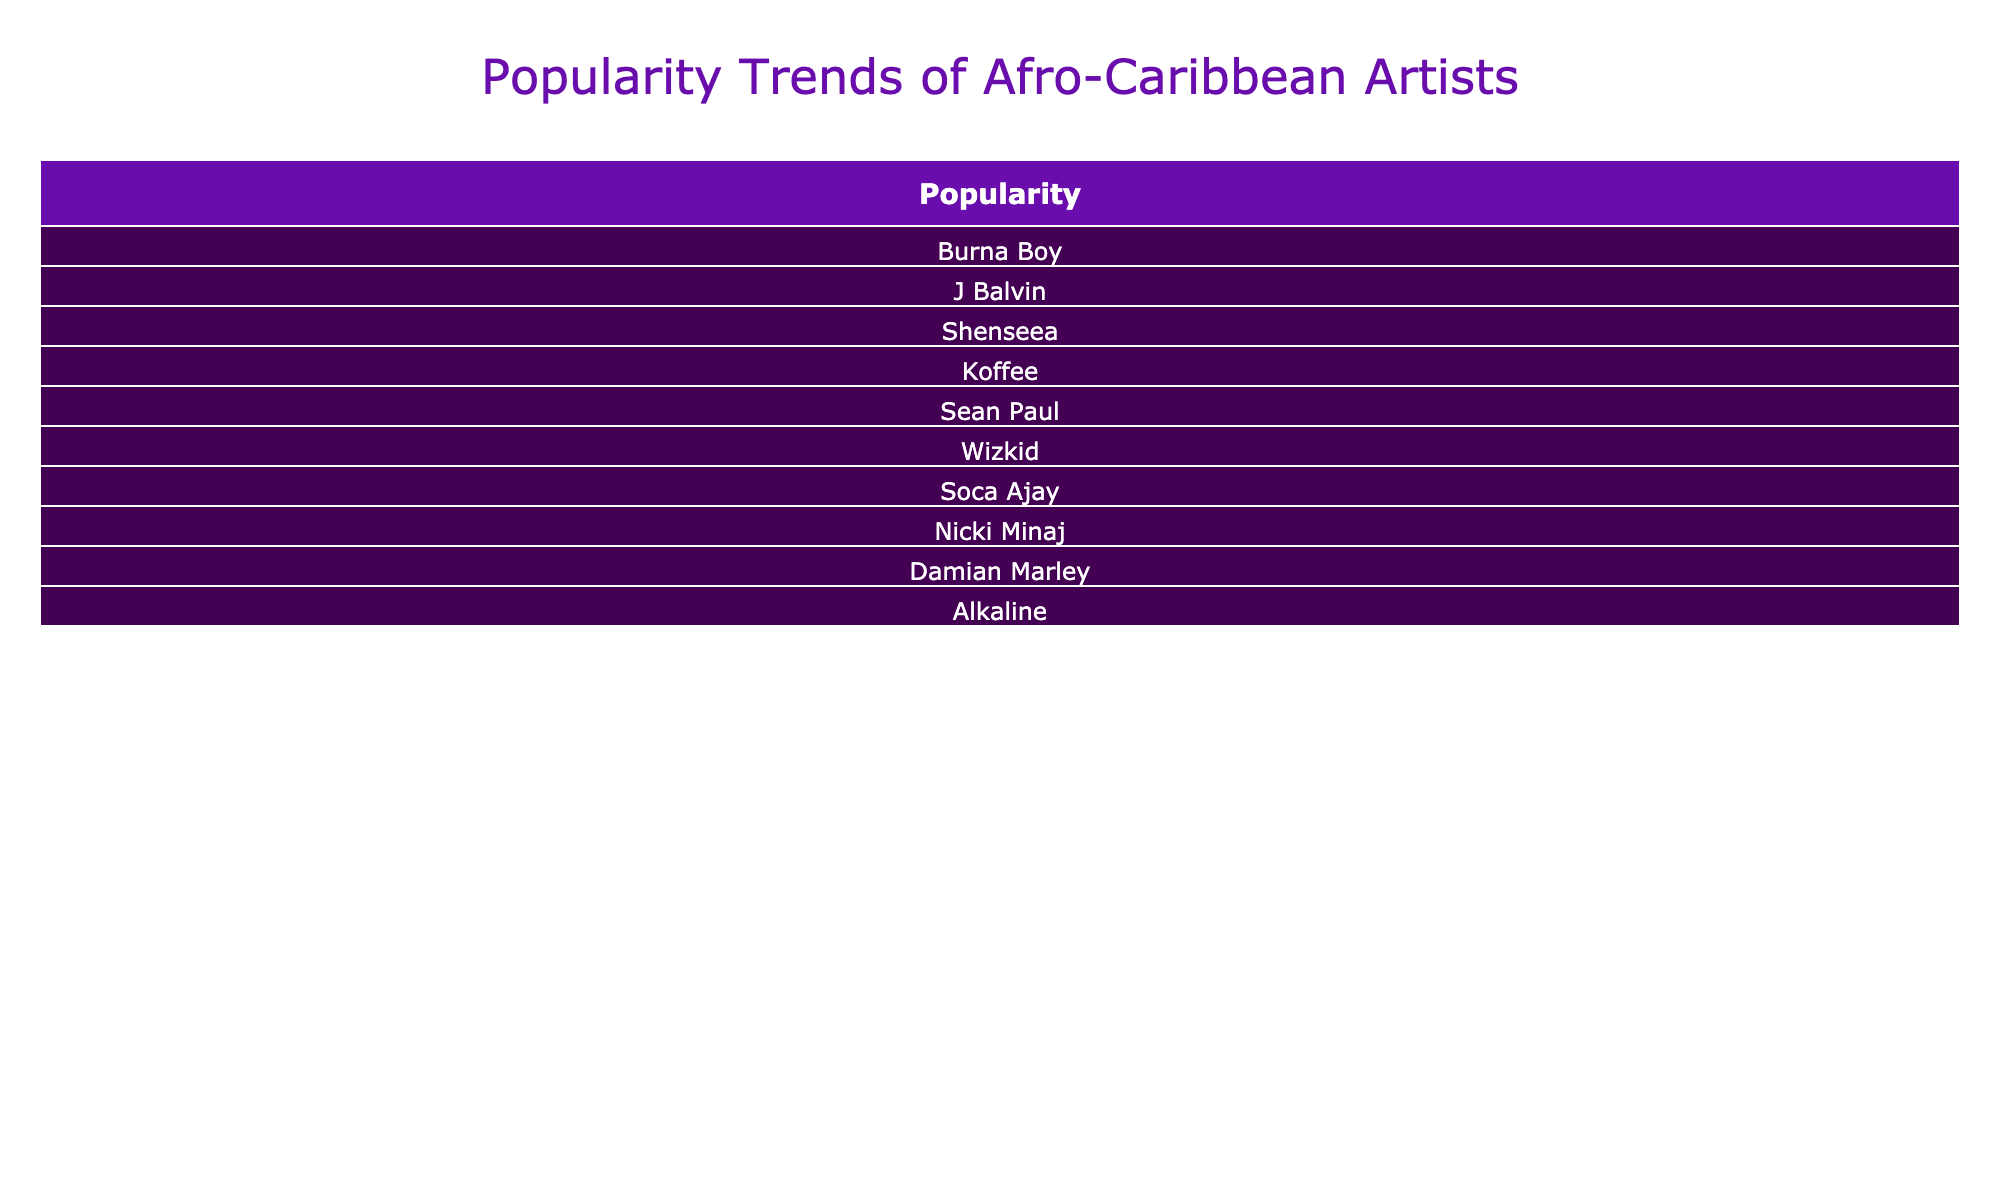What is the engagement rate for Burna Boy on Instagram? The table shows that Burna Boy has an engagement rate of 0.12 on Instagram. This value is directly retrievable from the "Engagement Rate" column corresponding to Burna Boy's data.
Answer: 0.12 Which artist has the highest number of followers? Upon reviewing the "Followers/Streams" column, J Balvin has the highest count with 35,000,000 followers on TikTok. This is the maximum value when comparing all artists in the table.
Answer: 35,000,000 What is the average engagement rate of the artists listed? The engagement rates are: 0.12, 0.15, 0.10, 0.08, 0.14, 0.20, 0.04, 0.11, 0.09, 0.07. First, sum these rates to get 0.12 + 0.15 + 0.10 + 0.08 + 0.14 + 0.20 + 0.04 + 0.11 + 0.09 + 0.07 = 1.1. Next, divide by the total number of artists, which is 10. Thus, 1.1 / 10 = 0.11.
Answer: 0.11 Is Nicki Minaj's engagement rate greater than Koffee's? By looking at the "Engagement Rate" column, Nicki Minaj has an engagement rate of 0.11, while Koffee's rate is 0.08. Since 0.11 is greater than 0.08, the answer is yes.
Answer: Yes What is the difference in followers between Wizkid and Shenseea? Wizkid has 25,000,000 followers on Spotify, while Shenseea has 5,000,000 followers on YouTube. To find the difference, subtract Shenseea's followers from Wizkid's: 25,000,000 - 5,000,000 = 20,000,000.
Answer: 20,000,000 Which platform has the lowest engagement rate among the artists listed? After checking the engagement rates per platform, Soca Ajay on Instagram has the lowest engagement rate at 0.04. This is the minimum value found in the "Engagement Rate" column.
Answer: 0.04 How many artists have an engagement rate over 0.10? By examining the "Engagement Rate" column, the following rates are above 0.10: 0.12 (Burna Boy), 0.15 (J Balvin), 0.14 (Sean Paul), 0.20 (Wizkid), and 0.11 (Nicki Minaj). There are 5 artists in total that meet this criterion.
Answer: 5 Are there any artists on Twitter with an engagement rate below 0.10? Looking at the "Engagement Rate" for Twitter, Koffee has 0.08 and Alkaline has 0.07. Since both values are below 0.10, the answer is yes.
Answer: Yes What is the total number of followers for all artists on Instagram? On Instagram, the followers are: Burna Boy (10,000,000) and Soca Ajay (3,000,000). Summing them gives 10,000,000 + 3,000,000 = 13,000,000.
Answer: 13,000,000 